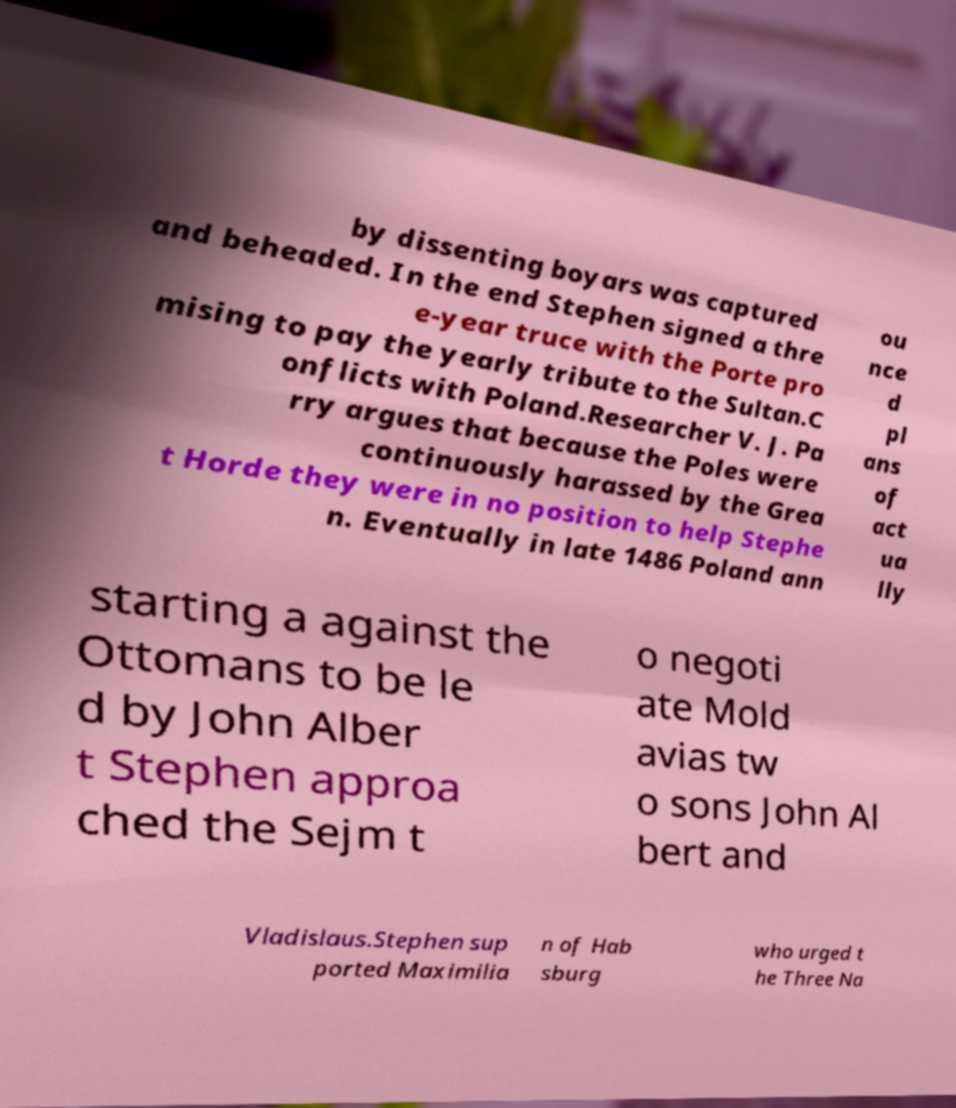Can you accurately transcribe the text from the provided image for me? by dissenting boyars was captured and beheaded. In the end Stephen signed a thre e-year truce with the Porte pro mising to pay the yearly tribute to the Sultan.C onflicts with Poland.Researcher V. J. Pa rry argues that because the Poles were continuously harassed by the Grea t Horde they were in no position to help Stephe n. Eventually in late 1486 Poland ann ou nce d pl ans of act ua lly starting a against the Ottomans to be le d by John Alber t Stephen approa ched the Sejm t o negoti ate Mold avias tw o sons John Al bert and Vladislaus.Stephen sup ported Maximilia n of Hab sburg who urged t he Three Na 